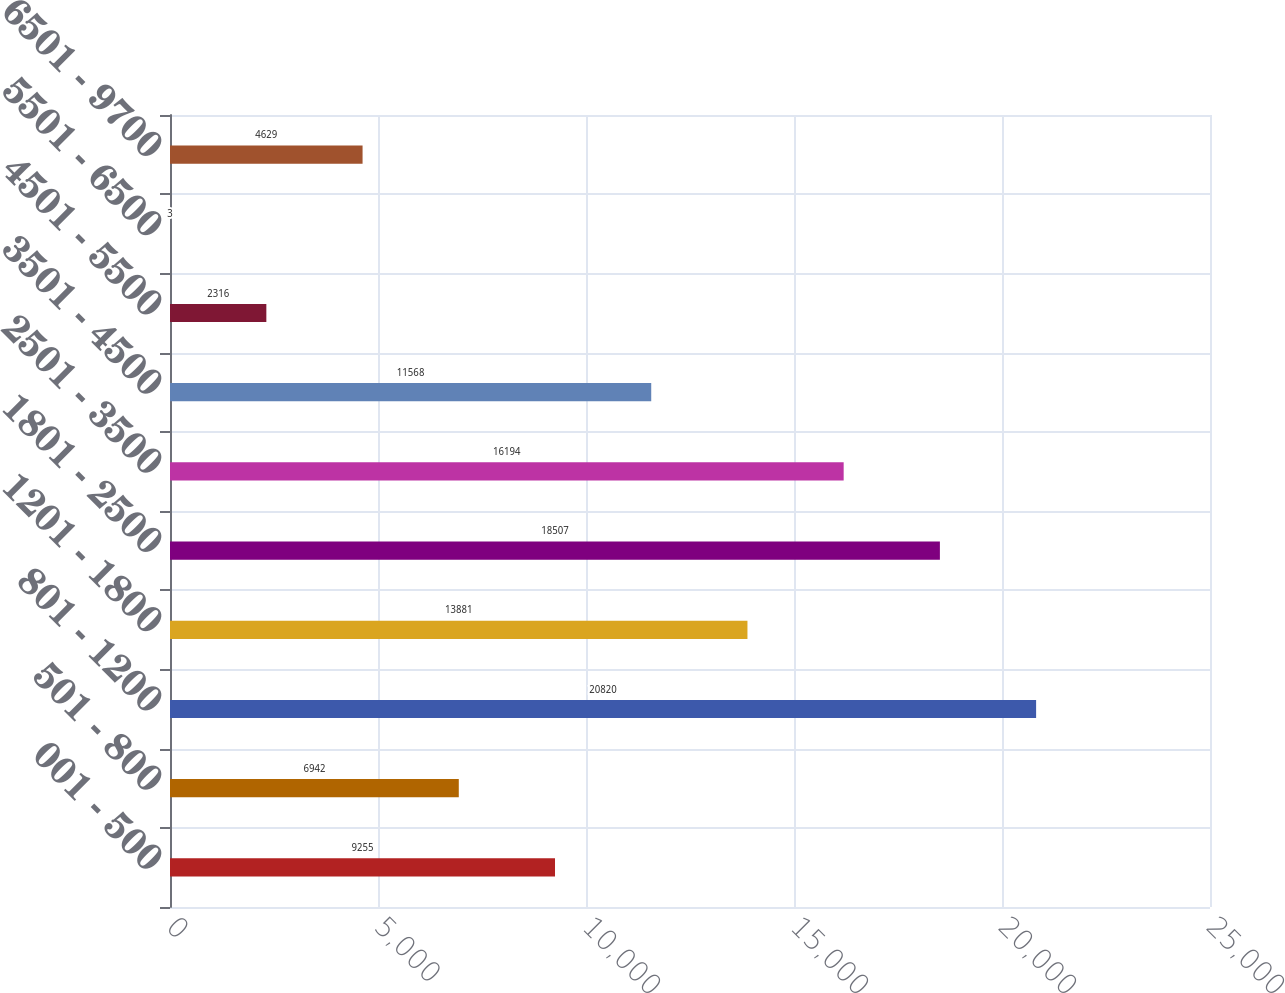Convert chart to OTSL. <chart><loc_0><loc_0><loc_500><loc_500><bar_chart><fcel>001 - 500<fcel>501 - 800<fcel>801 - 1200<fcel>1201 - 1800<fcel>1801 - 2500<fcel>2501 - 3500<fcel>3501 - 4500<fcel>4501 - 5500<fcel>5501 - 6500<fcel>6501 - 9700<nl><fcel>9255<fcel>6942<fcel>20820<fcel>13881<fcel>18507<fcel>16194<fcel>11568<fcel>2316<fcel>3<fcel>4629<nl></chart> 